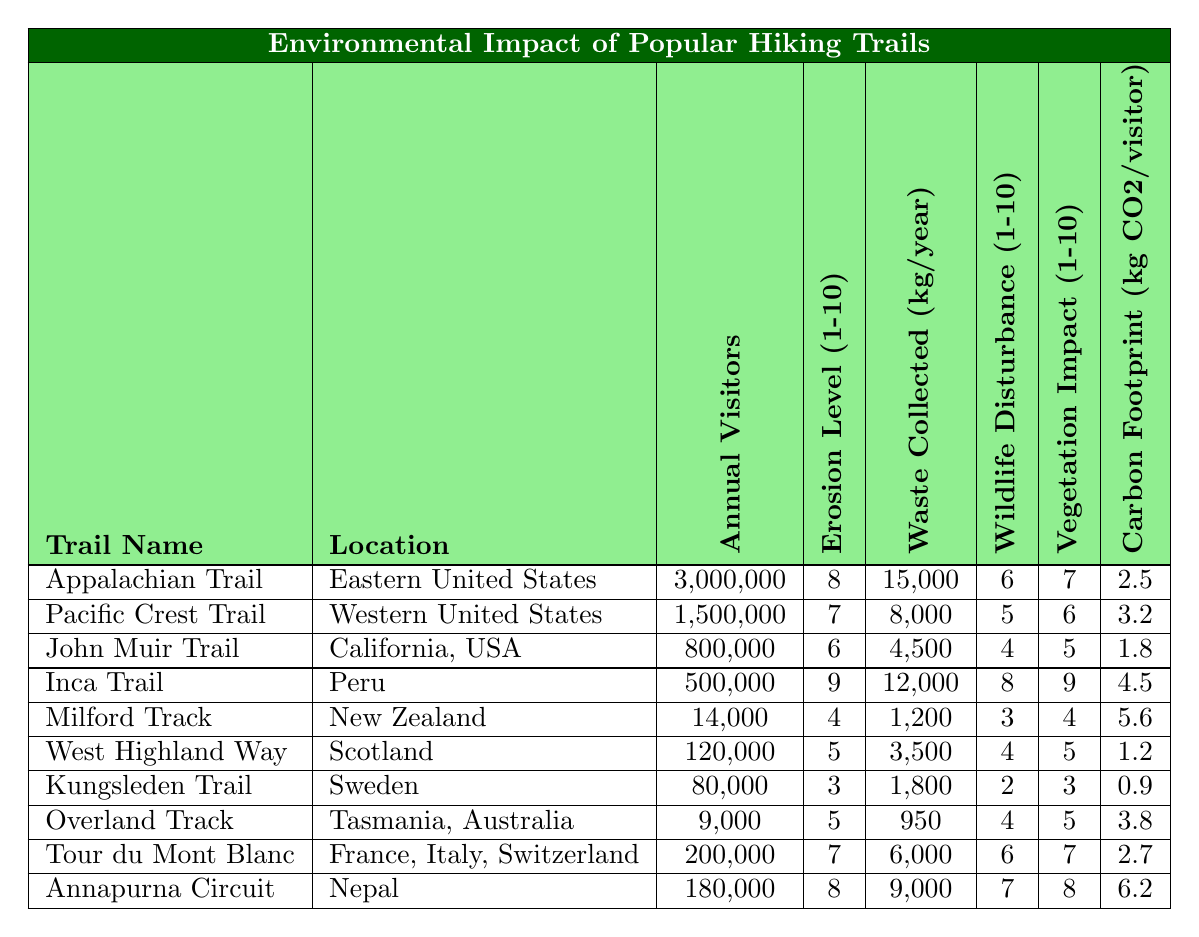What is the location of the Appalachian Trail? The table lists the Appalachian Trail under the "Location" column, which states it is in the Eastern United States.
Answer: Eastern United States How many annual visitors does the Inca Trail receive? In the table, the "Annual Visitors" column for the Inca Trail shows it receives 500,000 visitors each year.
Answer: 500,000 Which trail has the highest erosion level? By comparing the "Erosion Level (1-10)" column, the Inca Trail is noted for having the highest erosion level of 9.
Answer: Inca Trail What is the total waste collected annually from the Appalachian and Pacific Crest Trails combined? The waste collected from the Appalachian Trail is 15,000 kg and from the Pacific Crest Trail is 8,000 kg. Total waste = 15,000 + 8,000 = 23,000 kg.
Answer: 23,000 kg Is the Wildlife Disturbance level of the John Muir Trail higher than that of the West Highland Way? Comparing the "Wildlife Disturbance (1-10)" column, the John Muir Trail has a score of 4, while the West Highland Way has a score of 4. Since they have the same score, the statement is false.
Answer: No What is the carbon footprint per visitor of the Kungsleden Trail? The "Carbon Footprint (kg CO2/visitor)" column lists the Kungsleden Trail's carbon footprint as 0.9 kg CO2 per visitor.
Answer: 0.9 kg CO2 Which trail has the lowest vegetation impact? The lowest score in the "Vegetation Impact (1-10)" column is for the Kungsleden Trail, which has a score of 3.
Answer: Kungsleden Trail What is the average number of annual visitors among the trails listed? Calculate the total number of visitors: 3,000,000 + 1,500,000 + 800,000 + 500,000 + 14,000 + 120,000 + 80,000 + 9,000 + 200,000 + 180,000 = 6,113,000. Divide by the number of trails (10): 6,113,000 / 10 = 611,300.
Answer: 611,300 Which trail has the highest waste collection in kg/year? Searching the "Waste Collected (kg/year)" column, the Appalachian Trail has the highest value at 15,000 kg/year.
Answer: Appalachian Trail If a hiker visits all trails once, what is the total carbon footprint of those visits? Calculate the total carbon footprint: (2.5 + 3.2 + 1.8 + 4.5 + 5.6 + 1.2 + 0.9 + 3.8 + 2.7 + 6.2) kg CO2 = 32.4 kg CO2 for all trails.
Answer: 32.4 kg CO2 